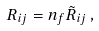Convert formula to latex. <formula><loc_0><loc_0><loc_500><loc_500>R _ { i j } = n _ { f } \tilde { R } _ { i j } \, ,</formula> 